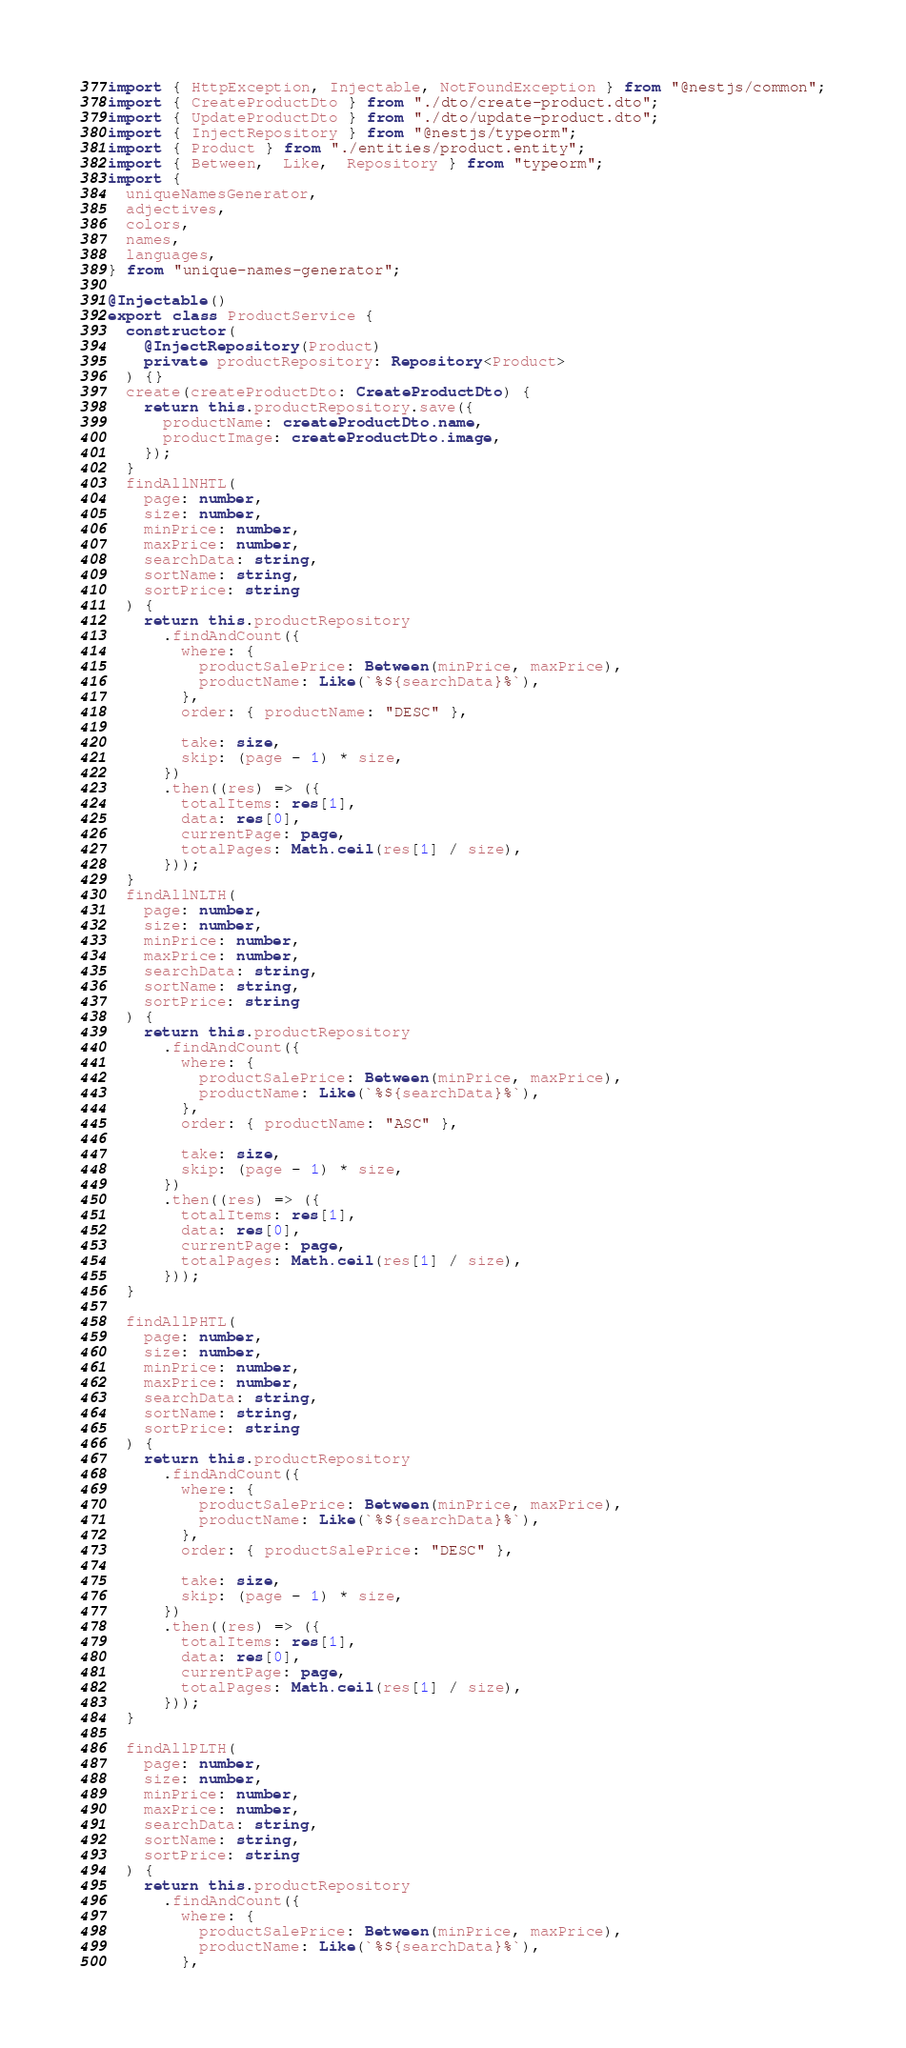<code> <loc_0><loc_0><loc_500><loc_500><_TypeScript_>import { HttpException, Injectable, NotFoundException } from "@nestjs/common";
import { CreateProductDto } from "./dto/create-product.dto";
import { UpdateProductDto } from "./dto/update-product.dto";
import { InjectRepository } from "@nestjs/typeorm";
import { Product } from "./entities/product.entity";
import { Between,  Like,  Repository } from "typeorm";
import {
  uniqueNamesGenerator,
  adjectives,
  colors,
  names,
  languages,
} from "unique-names-generator";

@Injectable()
export class ProductService {
  constructor(
    @InjectRepository(Product)
    private productRepository: Repository<Product>
  ) {}
  create(createProductDto: CreateProductDto) {
    return this.productRepository.save({
      productName: createProductDto.name,
      productImage: createProductDto.image,
    });
  }
  findAllNHTL(
    page: number,
    size: number,
    minPrice: number,
    maxPrice: number,
    searchData: string,
    sortName: string,
    sortPrice: string
  ) {
    return this.productRepository
      .findAndCount({
        where: {
          productSalePrice: Between(minPrice, maxPrice),
          productName: Like(`%${searchData}%`),
        },
        order: { productName: "DESC" },

        take: size,
        skip: (page - 1) * size,
      })
      .then((res) => ({
        totalItems: res[1],
        data: res[0],
        currentPage: page,
        totalPages: Math.ceil(res[1] / size),
      }));
  }
  findAllNLTH(
    page: number,
    size: number,
    minPrice: number,
    maxPrice: number,
    searchData: string,
    sortName: string,
    sortPrice: string
  ) {
    return this.productRepository
      .findAndCount({
        where: {
          productSalePrice: Between(minPrice, maxPrice),
          productName: Like(`%${searchData}%`),
        },
        order: { productName: "ASC" },

        take: size,
        skip: (page - 1) * size,
      })
      .then((res) => ({
        totalItems: res[1],
        data: res[0],
        currentPage: page,
        totalPages: Math.ceil(res[1] / size),
      }));
  }

  findAllPHTL(
    page: number,
    size: number,
    minPrice: number,
    maxPrice: number,
    searchData: string,
    sortName: string,
    sortPrice: string
  ) {
    return this.productRepository
      .findAndCount({
        where: {
          productSalePrice: Between(minPrice, maxPrice),
          productName: Like(`%${searchData}%`),
        },
        order: { productSalePrice: "DESC" },

        take: size,
        skip: (page - 1) * size,
      })
      .then((res) => ({
        totalItems: res[1],
        data: res[0],
        currentPage: page,
        totalPages: Math.ceil(res[1] / size),
      }));
  }

  findAllPLTH(
    page: number,
    size: number,
    minPrice: number,
    maxPrice: number,
    searchData: string,
    sortName: string,
    sortPrice: string
  ) {
    return this.productRepository
      .findAndCount({
        where: {
          productSalePrice: Between(minPrice, maxPrice),
          productName: Like(`%${searchData}%`),
        },</code> 